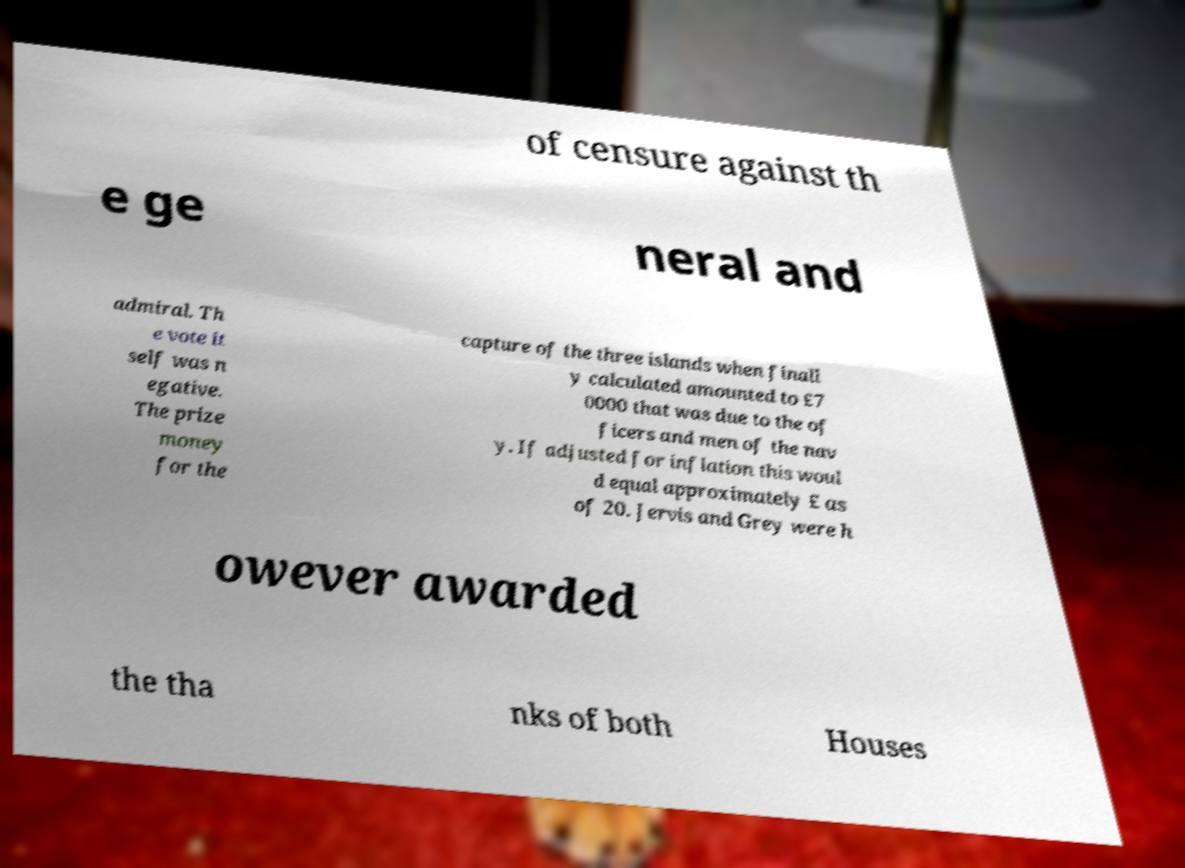Could you assist in decoding the text presented in this image and type it out clearly? of censure against th e ge neral and admiral. Th e vote it self was n egative. The prize money for the capture of the three islands when finall y calculated amounted to £7 0000 that was due to the of ficers and men of the nav y. If adjusted for inflation this woul d equal approximately £ as of 20. Jervis and Grey were h owever awarded the tha nks of both Houses 